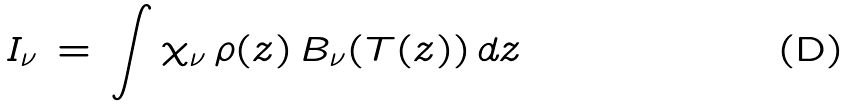Convert formula to latex. <formula><loc_0><loc_0><loc_500><loc_500>I _ { \nu } \, = \, { \int } \, { \chi } _ { \nu } \, { \rho } ( z ) \, B _ { \nu } ( T ( z ) ) \, d z</formula> 